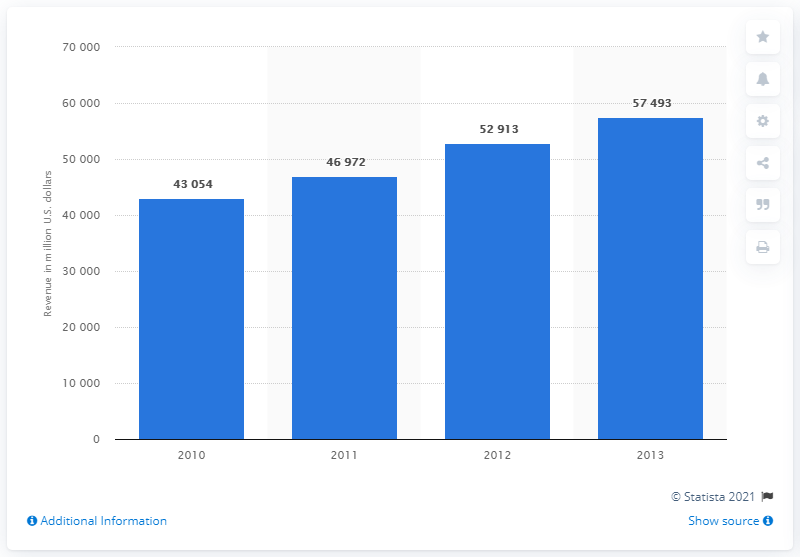Draw attention to some important aspects in this diagram. In the year 2013, the commercial or industrial equipment rental and leasing sector in the United States generated a revenue of 57,493. 